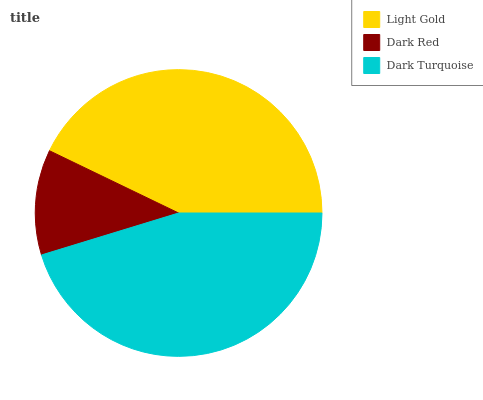Is Dark Red the minimum?
Answer yes or no. Yes. Is Dark Turquoise the maximum?
Answer yes or no. Yes. Is Dark Turquoise the minimum?
Answer yes or no. No. Is Dark Red the maximum?
Answer yes or no. No. Is Dark Turquoise greater than Dark Red?
Answer yes or no. Yes. Is Dark Red less than Dark Turquoise?
Answer yes or no. Yes. Is Dark Red greater than Dark Turquoise?
Answer yes or no. No. Is Dark Turquoise less than Dark Red?
Answer yes or no. No. Is Light Gold the high median?
Answer yes or no. Yes. Is Light Gold the low median?
Answer yes or no. Yes. Is Dark Turquoise the high median?
Answer yes or no. No. Is Dark Turquoise the low median?
Answer yes or no. No. 